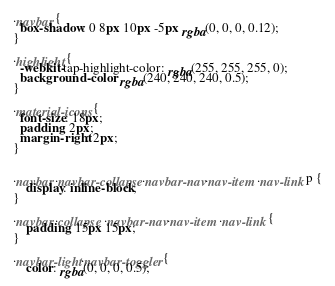<code> <loc_0><loc_0><loc_500><loc_500><_CSS_>
.navbar {
  box-shadow: 0 8px 10px -5px rgba(0, 0, 0, 0.12);
}

.highlight {
  -webkit-tap-highlight-color: rgba(255, 255, 255, 0);
  background-color: rgba(240, 240, 240, 0.5);
}

.material-icons {
  font-size: 18px;
  padding: 2px;
  margin-right: 2px;
}


.navbar .navbar-collapse .navbar-nav .nav-item .nav-link p {
    display: inline-block;
}

.navbar .collapse .navbar-nav .nav-item .nav-link {
    padding: 15px 15px;
}

.navbar-light .navbar-toggler {
    color: rgba(0, 0, 0, 0.5);</code> 